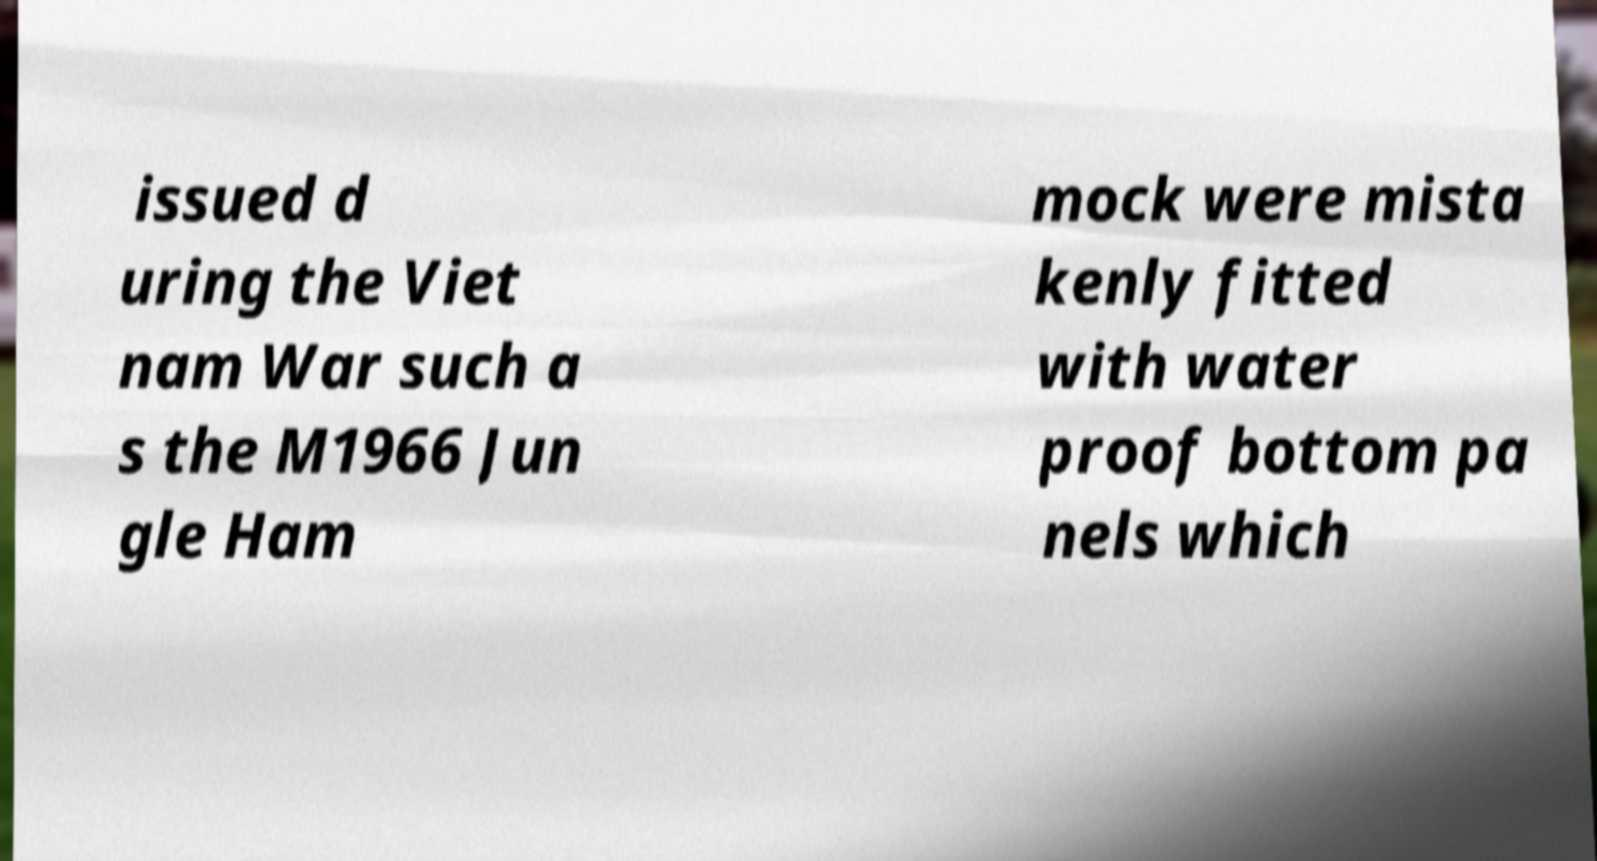Please identify and transcribe the text found in this image. issued d uring the Viet nam War such a s the M1966 Jun gle Ham mock were mista kenly fitted with water proof bottom pa nels which 